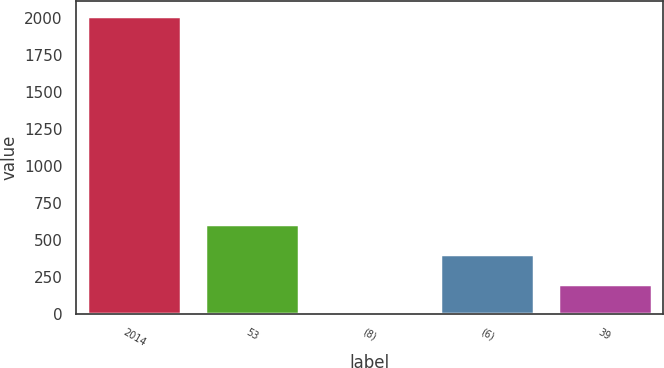Convert chart to OTSL. <chart><loc_0><loc_0><loc_500><loc_500><bar_chart><fcel>2014<fcel>53<fcel>(8)<fcel>(6)<fcel>39<nl><fcel>2013<fcel>604.6<fcel>1<fcel>403.4<fcel>202.2<nl></chart> 